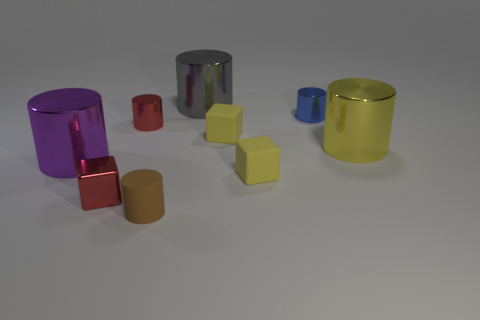What is the shape of the gray shiny thing that is the same size as the purple cylinder?
Make the answer very short. Cylinder. How many other things are there of the same color as the small rubber cylinder?
Offer a terse response. 0. How many other things are there of the same material as the big purple cylinder?
Offer a very short reply. 5. Is the size of the yellow cylinder the same as the cube to the left of the small brown cylinder?
Keep it short and to the point. No. What color is the small rubber cylinder?
Provide a short and direct response. Brown. There is a matte object behind the big cylinder to the left of the brown matte cylinder that is in front of the gray cylinder; what is its shape?
Your answer should be compact. Cube. There is a thing that is in front of the red object in front of the purple shiny object; what is its material?
Provide a succinct answer. Rubber. The red object that is made of the same material as the tiny red cylinder is what shape?
Offer a very short reply. Cube. Are there any other things that are the same shape as the tiny brown rubber object?
Offer a terse response. Yes. There is a tiny blue shiny object; how many small blue things are in front of it?
Offer a terse response. 0. 